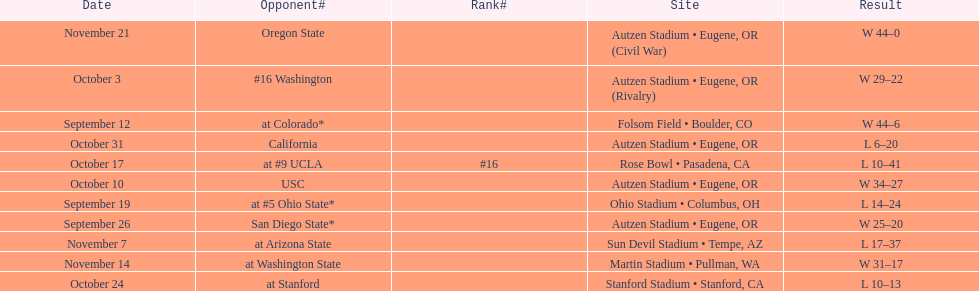How many wins are listed for the season? 6. 